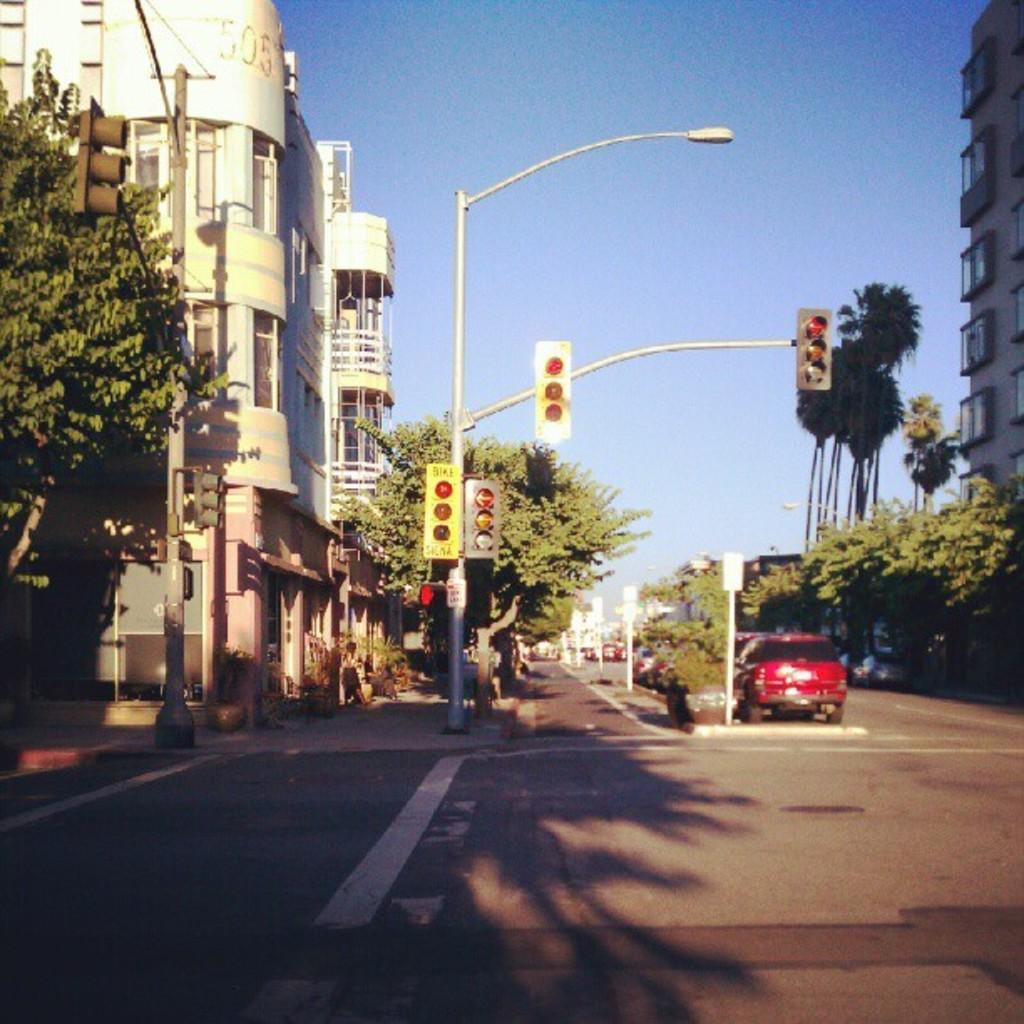What can be seen on the road in the image? There are vehicles on the road in the image. What structures are visible in the image? There are buildings visible in the image. What type of vegetation is present in the image? Trees are present in the image. What type of lighting is visible in the image? A street light and pole lights are present in the image. What else can be seen on the ground in the image? Other objects are present on the ground in the image. What is visible in the background of the image? The sky is visible in the background of the image. What type of linen is draped over the vehicles in the image? There is no linen draped over the vehicles in the image. What company is responsible for the street lights in the image? The image does not provide information about the company responsible for the street lights. 